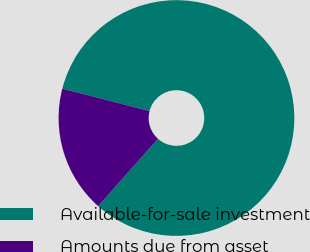Convert chart. <chart><loc_0><loc_0><loc_500><loc_500><pie_chart><fcel>Available-for-sale investment<fcel>Amounts due from asset<nl><fcel>82.55%<fcel>17.45%<nl></chart> 